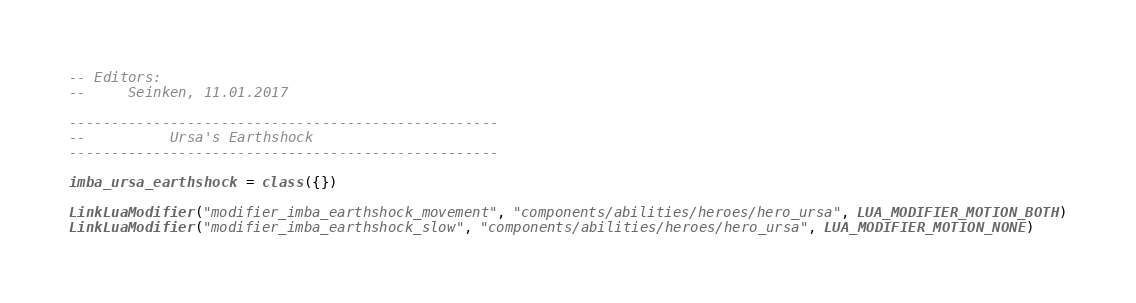Convert code to text. <code><loc_0><loc_0><loc_500><loc_500><_Lua_>-- Editors:
--     Seinken, 11.01.2017

---------------------------------------------------
--			Ursa's Earthshock
---------------------------------------------------

imba_ursa_earthshock = class({})

LinkLuaModifier("modifier_imba_earthshock_movement", "components/abilities/heroes/hero_ursa", LUA_MODIFIER_MOTION_BOTH)
LinkLuaModifier("modifier_imba_earthshock_slow", "components/abilities/heroes/hero_ursa", LUA_MODIFIER_MOTION_NONE)</code> 